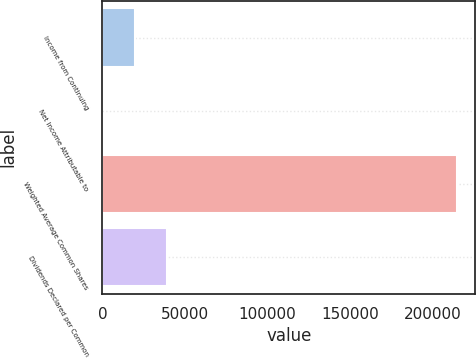<chart> <loc_0><loc_0><loc_500><loc_500><bar_chart><fcel>Income from Continuing<fcel>Net Income Attributable to<fcel>Weighted Average Common Shares<fcel>Dividends Declared per Common<nl><fcel>19676.4<fcel>1.67<fcel>214953<fcel>39351.1<nl></chart> 